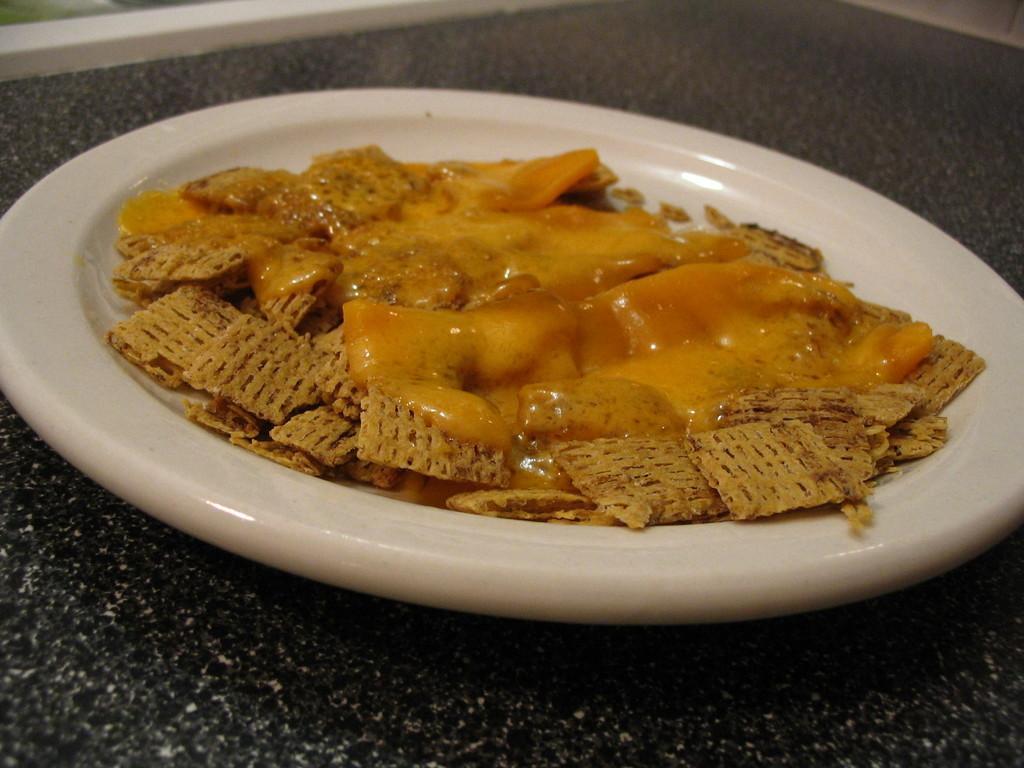Could you give a brief overview of what you see in this image? On the black color surface there is a white plate. On the plate there is a food item with a cream on it. 